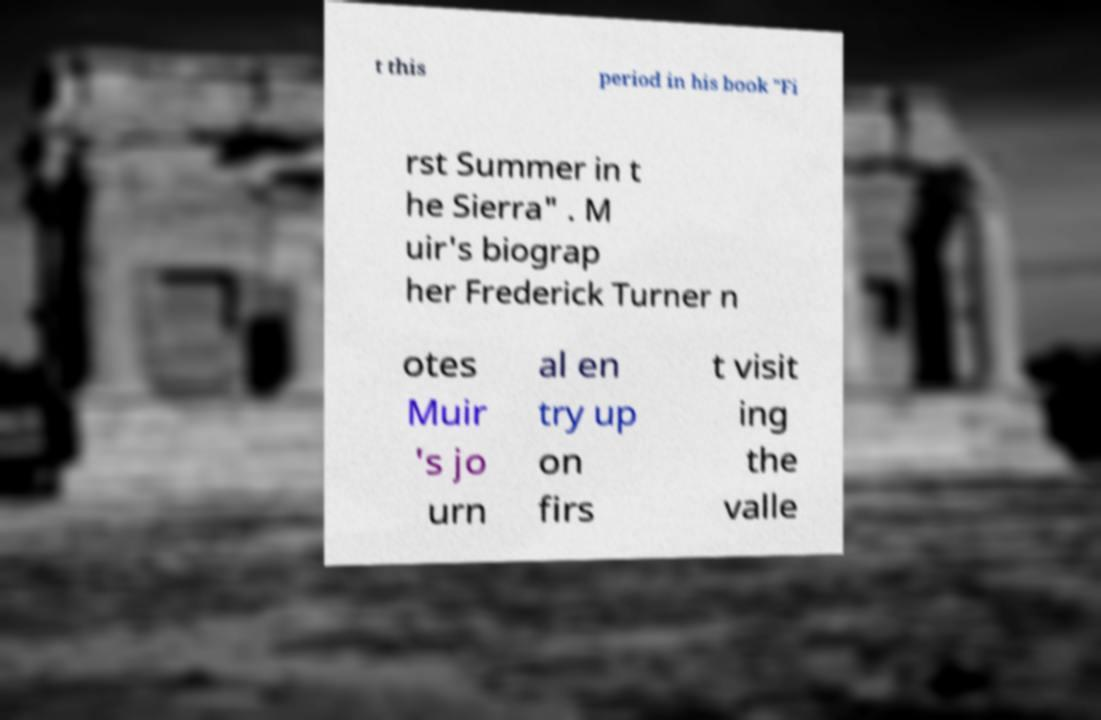Can you read and provide the text displayed in the image?This photo seems to have some interesting text. Can you extract and type it out for me? t this period in his book "Fi rst Summer in t he Sierra" . M uir's biograp her Frederick Turner n otes Muir 's jo urn al en try up on firs t visit ing the valle 